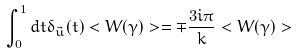Convert formula to latex. <formula><loc_0><loc_0><loc_500><loc_500>\int _ { 0 } ^ { 1 } d t \delta _ { \vec { u } } ( t ) < W ( \gamma ) > = \mp \frac { 3 i \pi } { k } < W ( \gamma ) ></formula> 